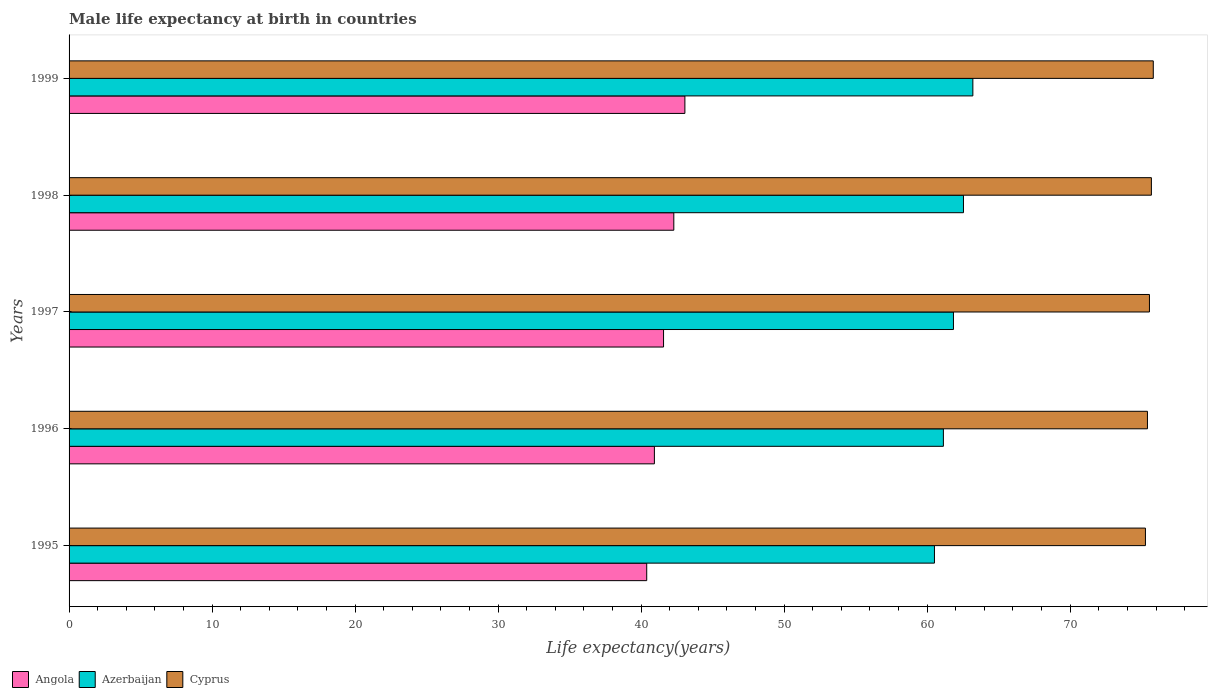How many different coloured bars are there?
Make the answer very short. 3. How many groups of bars are there?
Offer a very short reply. 5. Are the number of bars on each tick of the Y-axis equal?
Your response must be concise. Yes. How many bars are there on the 2nd tick from the top?
Keep it short and to the point. 3. In how many cases, is the number of bars for a given year not equal to the number of legend labels?
Provide a succinct answer. 0. What is the male life expectancy at birth in Azerbaijan in 1999?
Provide a succinct answer. 63.2. Across all years, what is the maximum male life expectancy at birth in Azerbaijan?
Give a very brief answer. 63.2. Across all years, what is the minimum male life expectancy at birth in Cyprus?
Make the answer very short. 75.26. In which year was the male life expectancy at birth in Angola minimum?
Offer a terse response. 1995. What is the total male life expectancy at birth in Cyprus in the graph?
Keep it short and to the point. 377.69. What is the difference between the male life expectancy at birth in Angola in 1997 and that in 1999?
Ensure brevity in your answer.  -1.49. What is the difference between the male life expectancy at birth in Angola in 1996 and the male life expectancy at birth in Azerbaijan in 1997?
Offer a very short reply. -20.91. What is the average male life expectancy at birth in Cyprus per year?
Make the answer very short. 75.54. In the year 1997, what is the difference between the male life expectancy at birth in Angola and male life expectancy at birth in Cyprus?
Your answer should be very brief. -33.98. In how many years, is the male life expectancy at birth in Angola greater than 2 years?
Your response must be concise. 5. What is the ratio of the male life expectancy at birth in Angola in 1997 to that in 1998?
Offer a terse response. 0.98. Is the male life expectancy at birth in Azerbaijan in 1995 less than that in 1997?
Offer a very short reply. Yes. What is the difference between the highest and the second highest male life expectancy at birth in Angola?
Make the answer very short. 0.77. What is the difference between the highest and the lowest male life expectancy at birth in Angola?
Offer a terse response. 2.67. Is the sum of the male life expectancy at birth in Angola in 1995 and 1999 greater than the maximum male life expectancy at birth in Cyprus across all years?
Keep it short and to the point. Yes. What does the 1st bar from the top in 1999 represents?
Offer a terse response. Cyprus. What does the 1st bar from the bottom in 1999 represents?
Make the answer very short. Angola. Is it the case that in every year, the sum of the male life expectancy at birth in Azerbaijan and male life expectancy at birth in Cyprus is greater than the male life expectancy at birth in Angola?
Make the answer very short. Yes. How many bars are there?
Provide a short and direct response. 15. Are all the bars in the graph horizontal?
Provide a succinct answer. Yes. What is the difference between two consecutive major ticks on the X-axis?
Provide a short and direct response. 10. Are the values on the major ticks of X-axis written in scientific E-notation?
Your response must be concise. No. What is the title of the graph?
Give a very brief answer. Male life expectancy at birth in countries. Does "Guatemala" appear as one of the legend labels in the graph?
Give a very brief answer. No. What is the label or title of the X-axis?
Provide a short and direct response. Life expectancy(years). What is the label or title of the Y-axis?
Your answer should be very brief. Years. What is the Life expectancy(years) of Angola in 1995?
Your response must be concise. 40.39. What is the Life expectancy(years) in Azerbaijan in 1995?
Your answer should be compact. 60.51. What is the Life expectancy(years) of Cyprus in 1995?
Provide a short and direct response. 75.26. What is the Life expectancy(years) of Angola in 1996?
Your answer should be compact. 40.93. What is the Life expectancy(years) of Azerbaijan in 1996?
Provide a short and direct response. 61.13. What is the Life expectancy(years) of Cyprus in 1996?
Provide a succinct answer. 75.4. What is the Life expectancy(years) of Angola in 1997?
Provide a succinct answer. 41.57. What is the Life expectancy(years) of Azerbaijan in 1997?
Your answer should be compact. 61.84. What is the Life expectancy(years) of Cyprus in 1997?
Your answer should be compact. 75.54. What is the Life expectancy(years) of Angola in 1998?
Ensure brevity in your answer.  42.28. What is the Life expectancy(years) in Azerbaijan in 1998?
Keep it short and to the point. 62.54. What is the Life expectancy(years) of Cyprus in 1998?
Make the answer very short. 75.68. What is the Life expectancy(years) in Angola in 1999?
Give a very brief answer. 43.06. What is the Life expectancy(years) in Azerbaijan in 1999?
Keep it short and to the point. 63.2. What is the Life expectancy(years) in Cyprus in 1999?
Give a very brief answer. 75.81. Across all years, what is the maximum Life expectancy(years) of Angola?
Offer a terse response. 43.06. Across all years, what is the maximum Life expectancy(years) of Azerbaijan?
Ensure brevity in your answer.  63.2. Across all years, what is the maximum Life expectancy(years) in Cyprus?
Offer a very short reply. 75.81. Across all years, what is the minimum Life expectancy(years) in Angola?
Make the answer very short. 40.39. Across all years, what is the minimum Life expectancy(years) in Azerbaijan?
Offer a very short reply. 60.51. Across all years, what is the minimum Life expectancy(years) of Cyprus?
Give a very brief answer. 75.26. What is the total Life expectancy(years) of Angola in the graph?
Keep it short and to the point. 208.23. What is the total Life expectancy(years) in Azerbaijan in the graph?
Your answer should be very brief. 309.21. What is the total Life expectancy(years) of Cyprus in the graph?
Keep it short and to the point. 377.69. What is the difference between the Life expectancy(years) in Angola in 1995 and that in 1996?
Make the answer very short. -0.54. What is the difference between the Life expectancy(years) of Azerbaijan in 1995 and that in 1996?
Your answer should be very brief. -0.62. What is the difference between the Life expectancy(years) of Cyprus in 1995 and that in 1996?
Provide a succinct answer. -0.14. What is the difference between the Life expectancy(years) in Angola in 1995 and that in 1997?
Make the answer very short. -1.18. What is the difference between the Life expectancy(years) in Azerbaijan in 1995 and that in 1997?
Offer a very short reply. -1.33. What is the difference between the Life expectancy(years) of Cyprus in 1995 and that in 1997?
Provide a short and direct response. -0.28. What is the difference between the Life expectancy(years) in Angola in 1995 and that in 1998?
Provide a succinct answer. -1.9. What is the difference between the Life expectancy(years) of Azerbaijan in 1995 and that in 1998?
Provide a succinct answer. -2.03. What is the difference between the Life expectancy(years) of Cyprus in 1995 and that in 1998?
Provide a short and direct response. -0.42. What is the difference between the Life expectancy(years) of Angola in 1995 and that in 1999?
Make the answer very short. -2.67. What is the difference between the Life expectancy(years) in Azerbaijan in 1995 and that in 1999?
Keep it short and to the point. -2.69. What is the difference between the Life expectancy(years) of Cyprus in 1995 and that in 1999?
Ensure brevity in your answer.  -0.55. What is the difference between the Life expectancy(years) in Angola in 1996 and that in 1997?
Give a very brief answer. -0.64. What is the difference between the Life expectancy(years) in Azerbaijan in 1996 and that in 1997?
Provide a short and direct response. -0.7. What is the difference between the Life expectancy(years) in Cyprus in 1996 and that in 1997?
Keep it short and to the point. -0.14. What is the difference between the Life expectancy(years) in Angola in 1996 and that in 1998?
Give a very brief answer. -1.36. What is the difference between the Life expectancy(years) of Azerbaijan in 1996 and that in 1998?
Keep it short and to the point. -1.4. What is the difference between the Life expectancy(years) in Cyprus in 1996 and that in 1998?
Provide a succinct answer. -0.28. What is the difference between the Life expectancy(years) of Angola in 1996 and that in 1999?
Provide a short and direct response. -2.13. What is the difference between the Life expectancy(years) in Azerbaijan in 1996 and that in 1999?
Provide a short and direct response. -2.06. What is the difference between the Life expectancy(years) in Cyprus in 1996 and that in 1999?
Provide a succinct answer. -0.41. What is the difference between the Life expectancy(years) in Angola in 1997 and that in 1998?
Offer a very short reply. -0.72. What is the difference between the Life expectancy(years) of Azerbaijan in 1997 and that in 1998?
Make the answer very short. -0.7. What is the difference between the Life expectancy(years) in Cyprus in 1997 and that in 1998?
Your response must be concise. -0.14. What is the difference between the Life expectancy(years) in Angola in 1997 and that in 1999?
Your answer should be very brief. -1.49. What is the difference between the Life expectancy(years) of Azerbaijan in 1997 and that in 1999?
Keep it short and to the point. -1.36. What is the difference between the Life expectancy(years) in Cyprus in 1997 and that in 1999?
Provide a short and direct response. -0.27. What is the difference between the Life expectancy(years) in Angola in 1998 and that in 1999?
Make the answer very short. -0.77. What is the difference between the Life expectancy(years) in Azerbaijan in 1998 and that in 1999?
Keep it short and to the point. -0.66. What is the difference between the Life expectancy(years) in Cyprus in 1998 and that in 1999?
Your answer should be very brief. -0.13. What is the difference between the Life expectancy(years) in Angola in 1995 and the Life expectancy(years) in Azerbaijan in 1996?
Make the answer very short. -20.74. What is the difference between the Life expectancy(years) of Angola in 1995 and the Life expectancy(years) of Cyprus in 1996?
Provide a succinct answer. -35.01. What is the difference between the Life expectancy(years) of Azerbaijan in 1995 and the Life expectancy(years) of Cyprus in 1996?
Provide a short and direct response. -14.89. What is the difference between the Life expectancy(years) of Angola in 1995 and the Life expectancy(years) of Azerbaijan in 1997?
Offer a terse response. -21.45. What is the difference between the Life expectancy(years) of Angola in 1995 and the Life expectancy(years) of Cyprus in 1997?
Keep it short and to the point. -35.15. What is the difference between the Life expectancy(years) of Azerbaijan in 1995 and the Life expectancy(years) of Cyprus in 1997?
Your response must be concise. -15.03. What is the difference between the Life expectancy(years) in Angola in 1995 and the Life expectancy(years) in Azerbaijan in 1998?
Give a very brief answer. -22.15. What is the difference between the Life expectancy(years) in Angola in 1995 and the Life expectancy(years) in Cyprus in 1998?
Provide a short and direct response. -35.29. What is the difference between the Life expectancy(years) of Azerbaijan in 1995 and the Life expectancy(years) of Cyprus in 1998?
Give a very brief answer. -15.17. What is the difference between the Life expectancy(years) of Angola in 1995 and the Life expectancy(years) of Azerbaijan in 1999?
Provide a short and direct response. -22.8. What is the difference between the Life expectancy(years) of Angola in 1995 and the Life expectancy(years) of Cyprus in 1999?
Provide a short and direct response. -35.42. What is the difference between the Life expectancy(years) of Azerbaijan in 1995 and the Life expectancy(years) of Cyprus in 1999?
Provide a succinct answer. -15.3. What is the difference between the Life expectancy(years) in Angola in 1996 and the Life expectancy(years) in Azerbaijan in 1997?
Give a very brief answer. -20.91. What is the difference between the Life expectancy(years) in Angola in 1996 and the Life expectancy(years) in Cyprus in 1997?
Give a very brief answer. -34.62. What is the difference between the Life expectancy(years) of Azerbaijan in 1996 and the Life expectancy(years) of Cyprus in 1997?
Offer a very short reply. -14.41. What is the difference between the Life expectancy(years) of Angola in 1996 and the Life expectancy(years) of Azerbaijan in 1998?
Offer a terse response. -21.61. What is the difference between the Life expectancy(years) of Angola in 1996 and the Life expectancy(years) of Cyprus in 1998?
Your answer should be very brief. -34.75. What is the difference between the Life expectancy(years) in Azerbaijan in 1996 and the Life expectancy(years) in Cyprus in 1998?
Give a very brief answer. -14.54. What is the difference between the Life expectancy(years) of Angola in 1996 and the Life expectancy(years) of Azerbaijan in 1999?
Provide a succinct answer. -22.27. What is the difference between the Life expectancy(years) in Angola in 1996 and the Life expectancy(years) in Cyprus in 1999?
Your response must be concise. -34.88. What is the difference between the Life expectancy(years) of Azerbaijan in 1996 and the Life expectancy(years) of Cyprus in 1999?
Make the answer very short. -14.68. What is the difference between the Life expectancy(years) in Angola in 1997 and the Life expectancy(years) in Azerbaijan in 1998?
Your answer should be very brief. -20.97. What is the difference between the Life expectancy(years) in Angola in 1997 and the Life expectancy(years) in Cyprus in 1998?
Offer a terse response. -34.11. What is the difference between the Life expectancy(years) in Azerbaijan in 1997 and the Life expectancy(years) in Cyprus in 1998?
Offer a terse response. -13.84. What is the difference between the Life expectancy(years) of Angola in 1997 and the Life expectancy(years) of Azerbaijan in 1999?
Give a very brief answer. -21.63. What is the difference between the Life expectancy(years) in Angola in 1997 and the Life expectancy(years) in Cyprus in 1999?
Provide a short and direct response. -34.24. What is the difference between the Life expectancy(years) in Azerbaijan in 1997 and the Life expectancy(years) in Cyprus in 1999?
Make the answer very short. -13.97. What is the difference between the Life expectancy(years) in Angola in 1998 and the Life expectancy(years) in Azerbaijan in 1999?
Offer a terse response. -20.91. What is the difference between the Life expectancy(years) in Angola in 1998 and the Life expectancy(years) in Cyprus in 1999?
Keep it short and to the point. -33.52. What is the difference between the Life expectancy(years) in Azerbaijan in 1998 and the Life expectancy(years) in Cyprus in 1999?
Make the answer very short. -13.27. What is the average Life expectancy(years) in Angola per year?
Provide a short and direct response. 41.65. What is the average Life expectancy(years) of Azerbaijan per year?
Provide a short and direct response. 61.84. What is the average Life expectancy(years) of Cyprus per year?
Keep it short and to the point. 75.54. In the year 1995, what is the difference between the Life expectancy(years) of Angola and Life expectancy(years) of Azerbaijan?
Your response must be concise. -20.12. In the year 1995, what is the difference between the Life expectancy(years) in Angola and Life expectancy(years) in Cyprus?
Provide a succinct answer. -34.87. In the year 1995, what is the difference between the Life expectancy(years) in Azerbaijan and Life expectancy(years) in Cyprus?
Provide a succinct answer. -14.75. In the year 1996, what is the difference between the Life expectancy(years) in Angola and Life expectancy(years) in Azerbaijan?
Provide a succinct answer. -20.21. In the year 1996, what is the difference between the Life expectancy(years) in Angola and Life expectancy(years) in Cyprus?
Provide a short and direct response. -34.48. In the year 1996, what is the difference between the Life expectancy(years) in Azerbaijan and Life expectancy(years) in Cyprus?
Make the answer very short. -14.27. In the year 1997, what is the difference between the Life expectancy(years) in Angola and Life expectancy(years) in Azerbaijan?
Provide a short and direct response. -20.27. In the year 1997, what is the difference between the Life expectancy(years) in Angola and Life expectancy(years) in Cyprus?
Make the answer very short. -33.98. In the year 1997, what is the difference between the Life expectancy(years) in Azerbaijan and Life expectancy(years) in Cyprus?
Provide a short and direct response. -13.7. In the year 1998, what is the difference between the Life expectancy(years) of Angola and Life expectancy(years) of Azerbaijan?
Your answer should be compact. -20.25. In the year 1998, what is the difference between the Life expectancy(years) in Angola and Life expectancy(years) in Cyprus?
Provide a succinct answer. -33.39. In the year 1998, what is the difference between the Life expectancy(years) of Azerbaijan and Life expectancy(years) of Cyprus?
Provide a succinct answer. -13.14. In the year 1999, what is the difference between the Life expectancy(years) of Angola and Life expectancy(years) of Azerbaijan?
Make the answer very short. -20.14. In the year 1999, what is the difference between the Life expectancy(years) of Angola and Life expectancy(years) of Cyprus?
Make the answer very short. -32.75. In the year 1999, what is the difference between the Life expectancy(years) in Azerbaijan and Life expectancy(years) in Cyprus?
Keep it short and to the point. -12.62. What is the ratio of the Life expectancy(years) in Angola in 1995 to that in 1996?
Your answer should be compact. 0.99. What is the ratio of the Life expectancy(years) of Azerbaijan in 1995 to that in 1996?
Provide a short and direct response. 0.99. What is the ratio of the Life expectancy(years) in Angola in 1995 to that in 1997?
Offer a very short reply. 0.97. What is the ratio of the Life expectancy(years) of Azerbaijan in 1995 to that in 1997?
Your answer should be very brief. 0.98. What is the ratio of the Life expectancy(years) of Angola in 1995 to that in 1998?
Keep it short and to the point. 0.96. What is the ratio of the Life expectancy(years) in Azerbaijan in 1995 to that in 1998?
Offer a terse response. 0.97. What is the ratio of the Life expectancy(years) of Cyprus in 1995 to that in 1998?
Your answer should be very brief. 0.99. What is the ratio of the Life expectancy(years) of Angola in 1995 to that in 1999?
Make the answer very short. 0.94. What is the ratio of the Life expectancy(years) in Azerbaijan in 1995 to that in 1999?
Your answer should be very brief. 0.96. What is the ratio of the Life expectancy(years) of Cyprus in 1995 to that in 1999?
Your response must be concise. 0.99. What is the ratio of the Life expectancy(years) in Angola in 1996 to that in 1997?
Your response must be concise. 0.98. What is the ratio of the Life expectancy(years) in Azerbaijan in 1996 to that in 1997?
Offer a very short reply. 0.99. What is the ratio of the Life expectancy(years) of Angola in 1996 to that in 1998?
Provide a short and direct response. 0.97. What is the ratio of the Life expectancy(years) in Azerbaijan in 1996 to that in 1998?
Provide a succinct answer. 0.98. What is the ratio of the Life expectancy(years) in Angola in 1996 to that in 1999?
Your response must be concise. 0.95. What is the ratio of the Life expectancy(years) in Azerbaijan in 1996 to that in 1999?
Keep it short and to the point. 0.97. What is the ratio of the Life expectancy(years) in Azerbaijan in 1997 to that in 1998?
Ensure brevity in your answer.  0.99. What is the ratio of the Life expectancy(years) of Angola in 1997 to that in 1999?
Make the answer very short. 0.97. What is the ratio of the Life expectancy(years) of Azerbaijan in 1997 to that in 1999?
Give a very brief answer. 0.98. What is the ratio of the Life expectancy(years) of Azerbaijan in 1998 to that in 1999?
Give a very brief answer. 0.99. What is the difference between the highest and the second highest Life expectancy(years) in Angola?
Your answer should be very brief. 0.77. What is the difference between the highest and the second highest Life expectancy(years) of Azerbaijan?
Offer a terse response. 0.66. What is the difference between the highest and the second highest Life expectancy(years) of Cyprus?
Give a very brief answer. 0.13. What is the difference between the highest and the lowest Life expectancy(years) in Angola?
Offer a terse response. 2.67. What is the difference between the highest and the lowest Life expectancy(years) of Azerbaijan?
Keep it short and to the point. 2.69. What is the difference between the highest and the lowest Life expectancy(years) in Cyprus?
Your response must be concise. 0.55. 